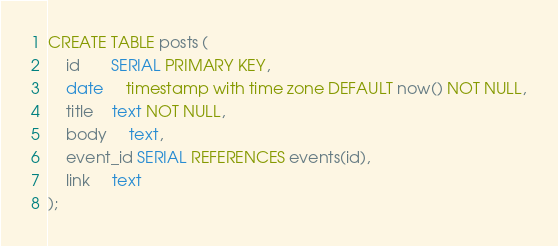Convert code to text. <code><loc_0><loc_0><loc_500><loc_500><_SQL_>CREATE TABLE posts (
    id       SERIAL PRIMARY KEY,
    date     timestamp with time zone DEFAULT now() NOT NULL,
    title    text NOT NULL,
    body     text,
    event_id SERIAL REFERENCES events(id),
    link     text
);
</code> 